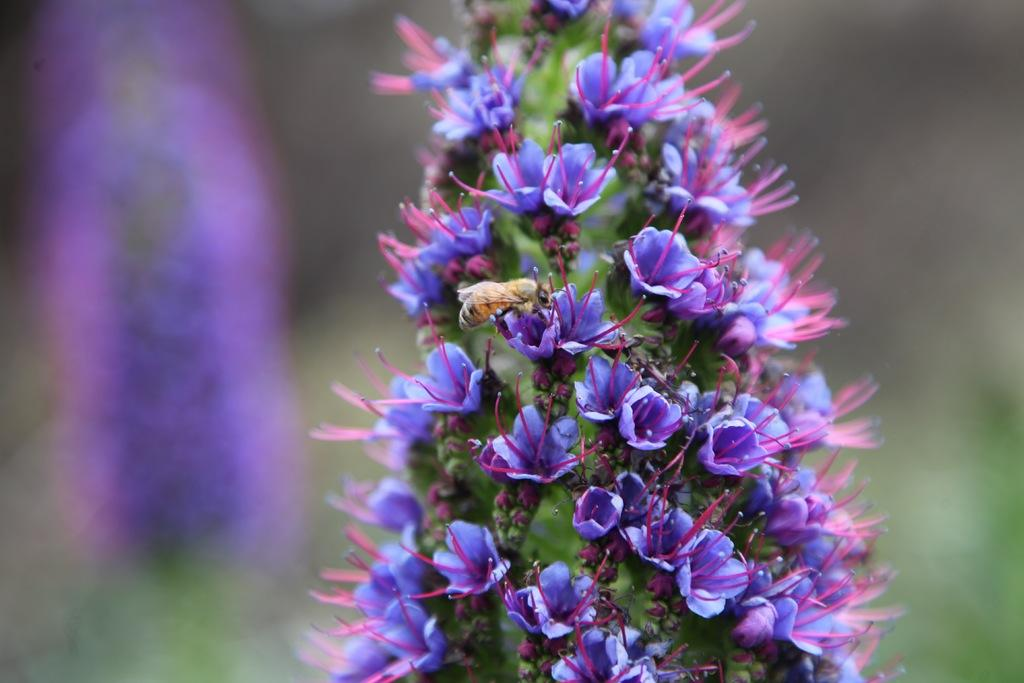What type of plant is visible in the image? There is a flower plant in the image. How many bats are hanging from the flower plant in the image? There are no bats present in the image; it features a flower plant. What type of jelly is being used to decorate the flower plant in the image? There is no jelly present in the image; it features a flower plant. 